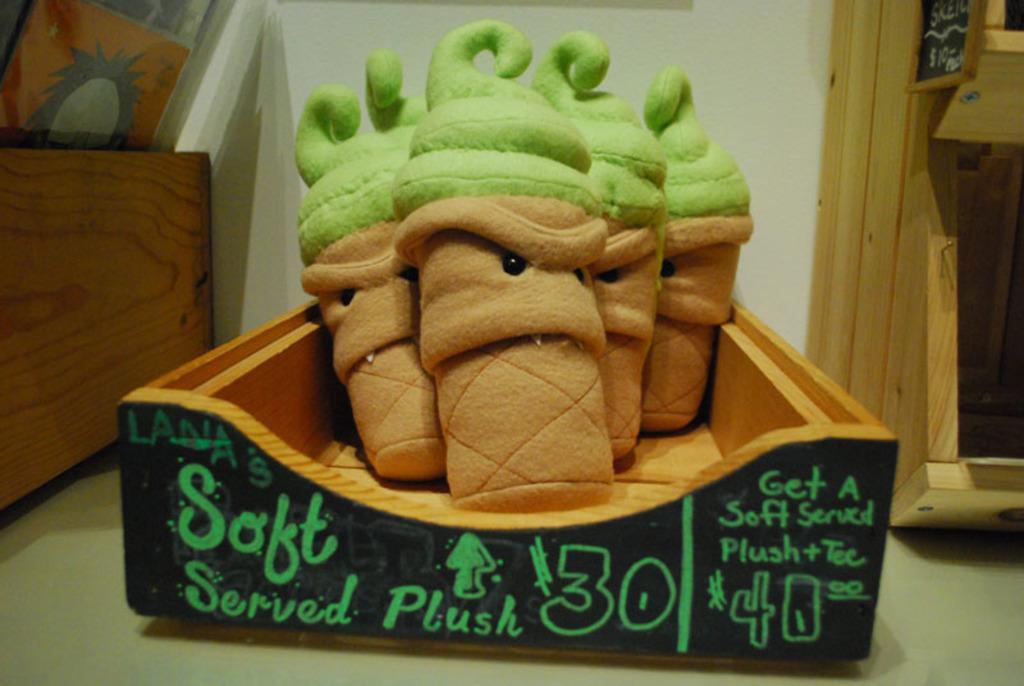Can you describe this image briefly? In this picture we can see toys in the box and this box is on the platform and in the background we can see the wall, wooden objects and a poster. 